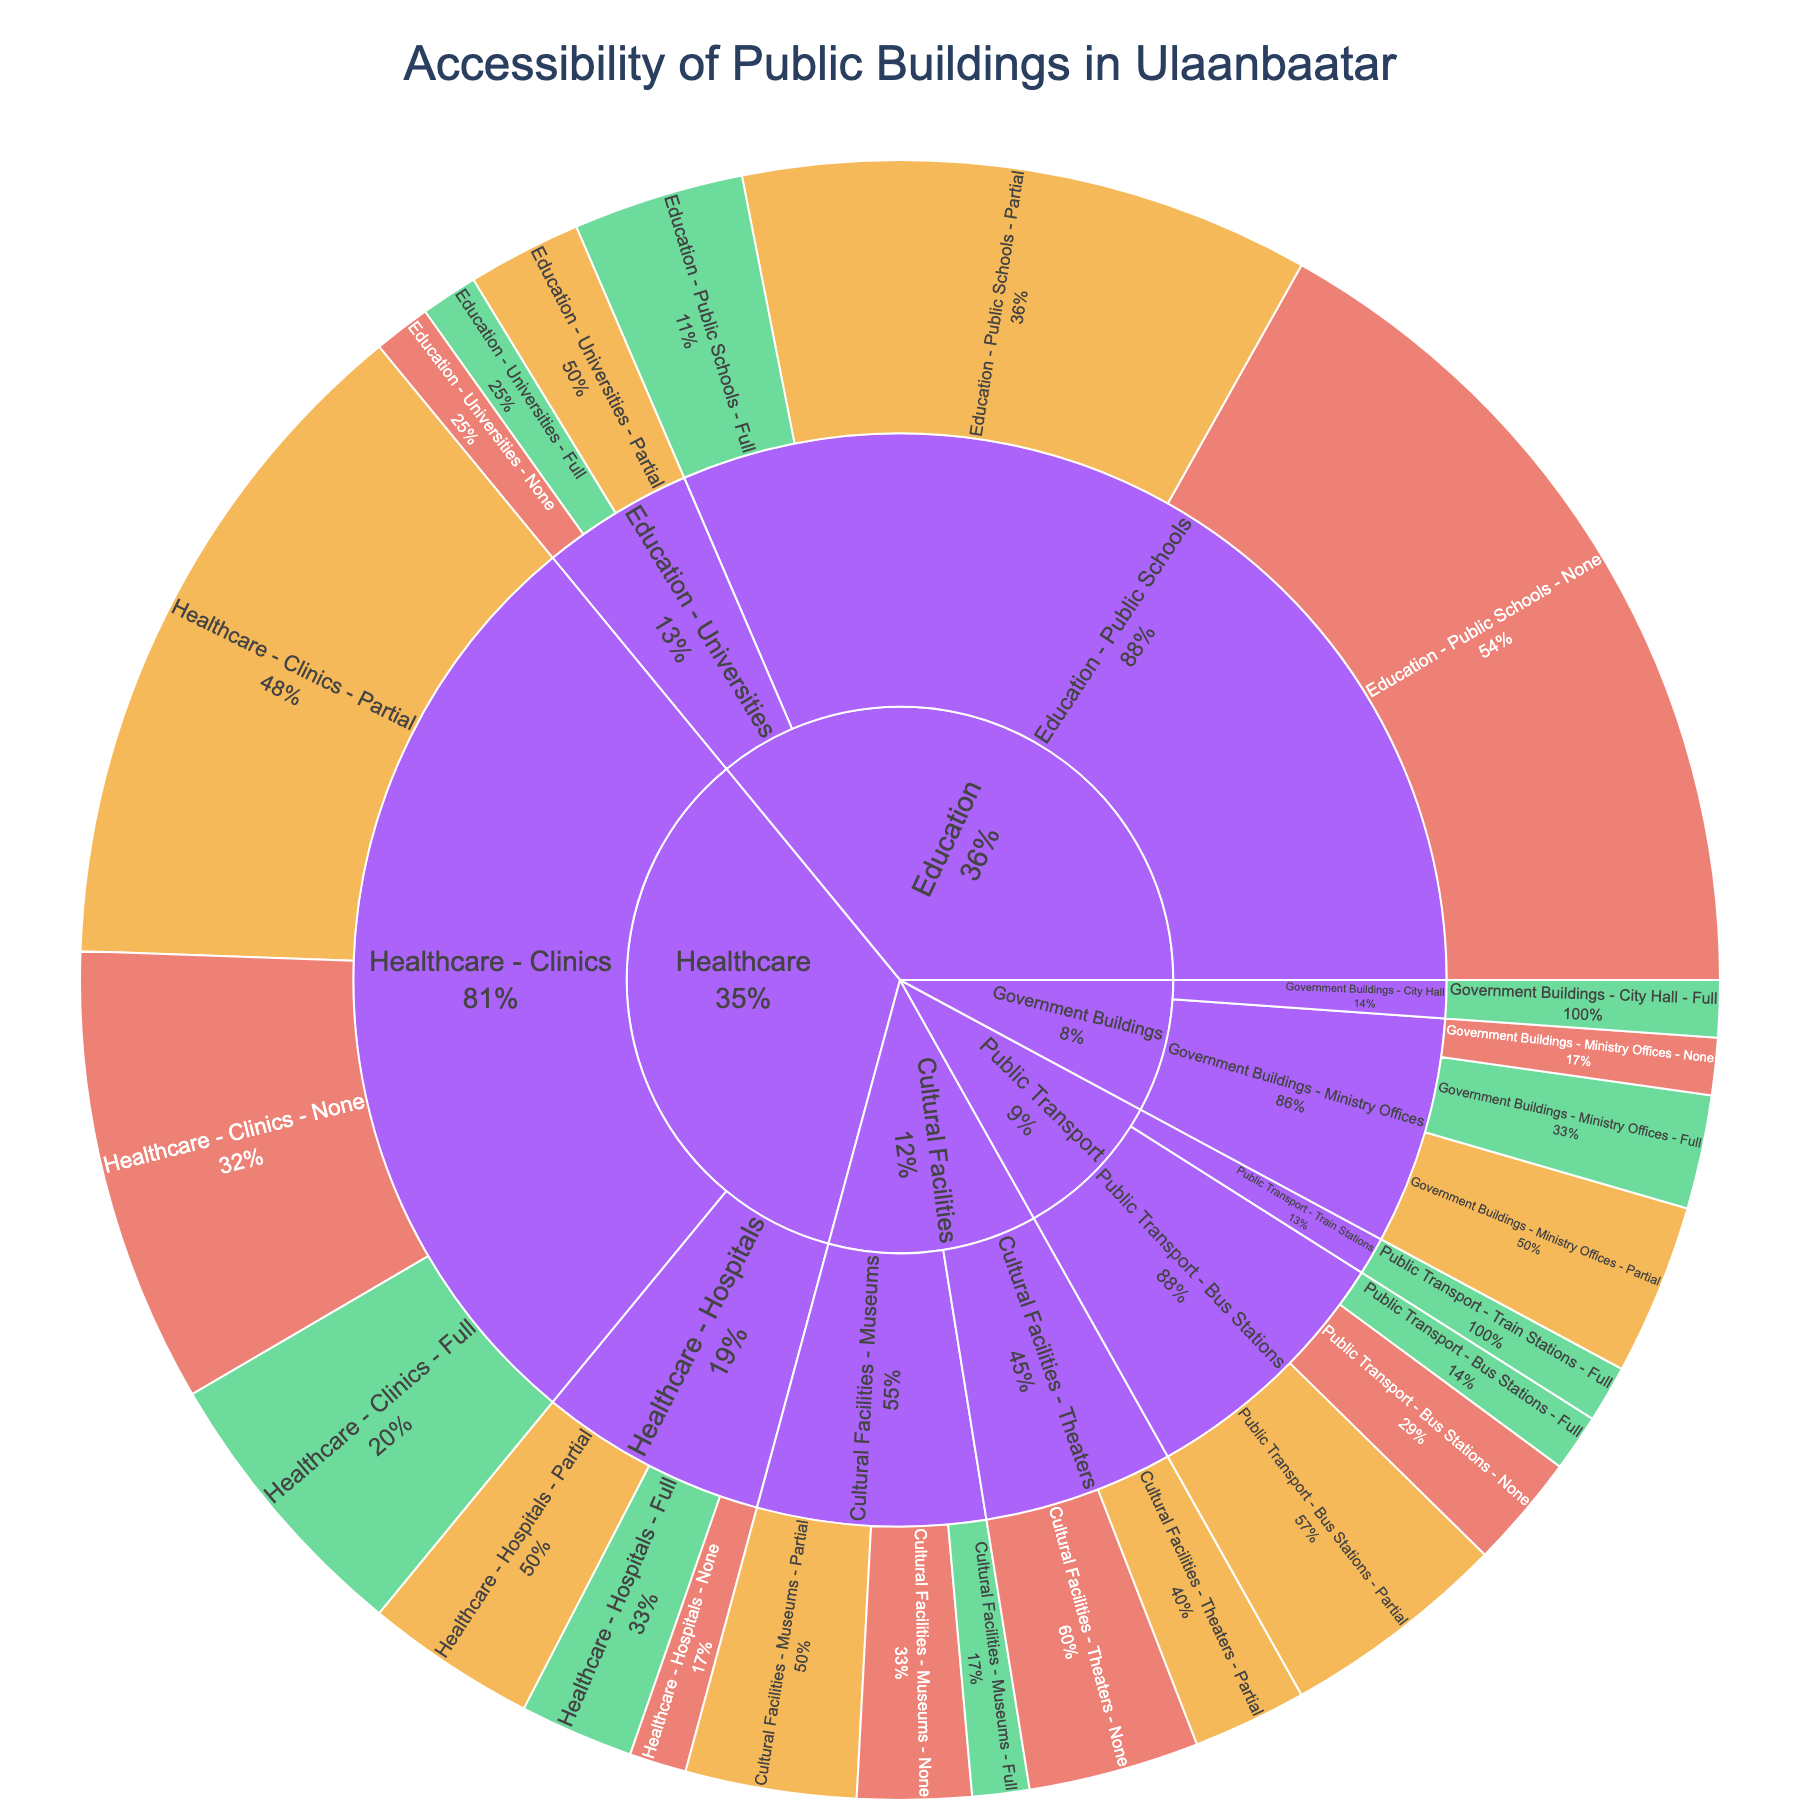What is the title of the figure? The title is displayed at the top of the figure in a larger and bold font.
Answer: Accessibility of Public Buildings in Ulaanbaatar Which facility type has the most buildings with full accessibility? Look at the section with green color representing 'Full' in the Sunburst plot and find the facility type portion with the largest segment.
Answer: Healthcare How many public schools have no accessibility? Navigate to the 'Education' section and then to 'Public Schools' and identify the red color segment labeled 'None'.
Answer: 15 Compare the number of fully accessible ministry offices with fully accessible hospitals. Look at the 'Government Buildings' section for 'Ministry Offices' and count the 'Full' accessibility; then look at 'Healthcare' section for 'Hospitals' and count their 'Full' accessibility.
Answer: Ministry Offices: 2, Hospitals: 2 What percentage of bus stations have partial accessibility? Locate 'Public Transport' and then 'Bus Stations'; for the orange (partial) segment, find its percentage relative to the 'Bus Stations' section.
Answer: 57.1% Which healthcare subcategory has the least number of partially accessible buildings? Observe both 'Hospitals' and 'Clinics' under the 'Healthcare' section for the orange segments and compare their counts.
Answer: Hospitals What is the total number of facilities with no accessibility among public transport facilities? Sum the counts of 'None' accessible in 'Bus Stations' and 'Train Stations'.
Answer: 2 + 0 = 2 How does the number of fully accessible public transport facilities compare to fully accessible cultural facilities? Compare the green segments for 'Public Transport' and 'Cultural Facilities'.
Answer: Public Transport: 2, Cultural Facilities: 1 What percentage of universities have full accessibility? Look at the 'Education' section and focus on 'Universities'; find the 'Full' accessibility segment and calculate its portion out of the total for 'Universities'.
Answer: 20% Which subcategory in cultural facilities has no fully accessible entries at all? Browse through 'Museums' and 'Theaters' under 'Cultural Facilities' and see if either has a green segment missing.
Answer: Theaters 